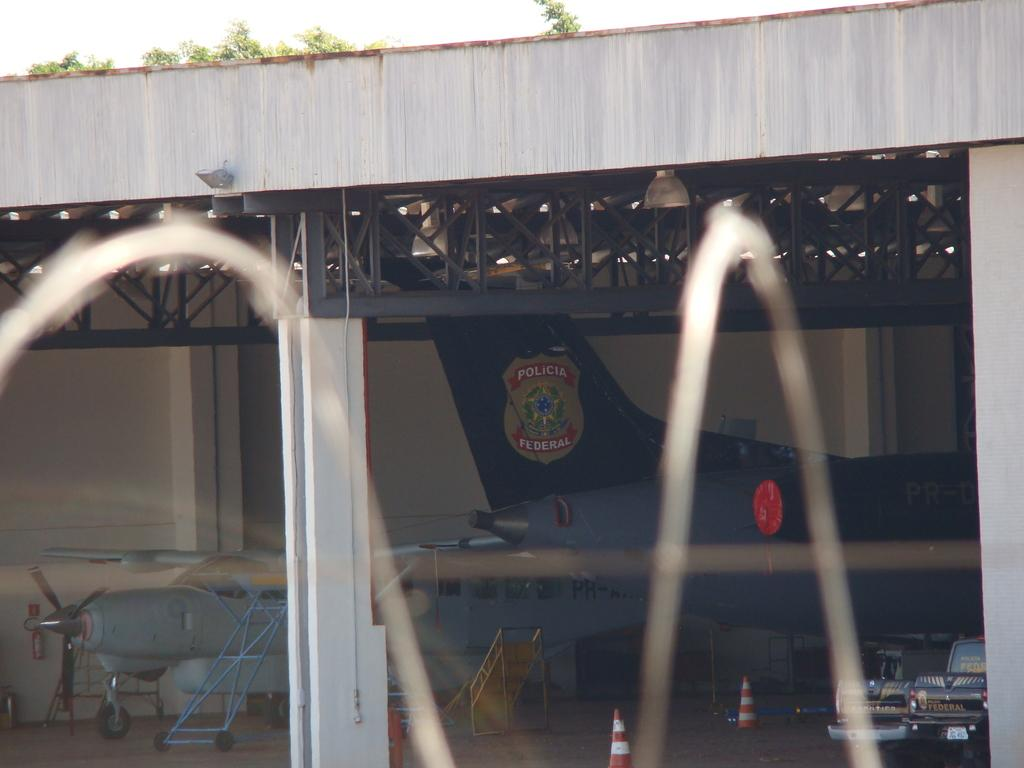What structure can be seen in the image? There is a bridge in the image. What else is present near the bridge? Police aircrafts are parked on the ground under the bridge. What type of tea is your grandmother brewing in the kettle in the image? There is no grandmother or kettle present in the image. What shape is the bridge in the image? The shape of the bridge cannot be determined from the image alone, as only a portion of the bridge is visible. 